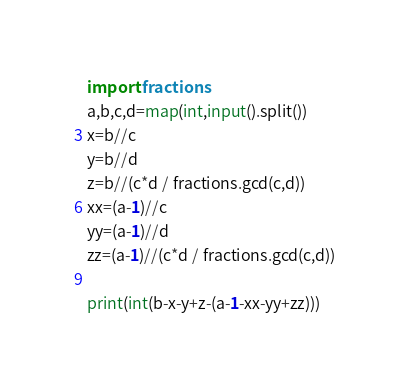<code> <loc_0><loc_0><loc_500><loc_500><_Python_>import fractions
a,b,c,d=map(int,input().split())
x=b//c
y=b//d
z=b//(c*d / fractions.gcd(c,d))
xx=(a-1)//c
yy=(a-1)//d
zz=(a-1)//(c*d / fractions.gcd(c,d))

print(int(b-x-y+z-(a-1-xx-yy+zz)))

</code> 